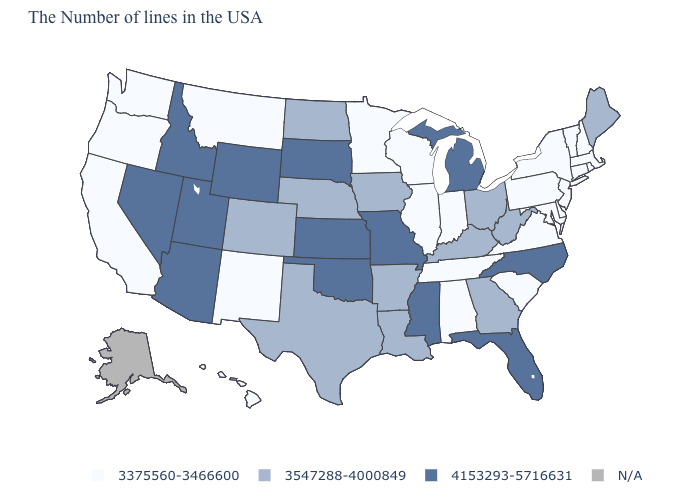What is the value of Florida?
Concise answer only. 4153293-5716631. Among the states that border Delaware , which have the lowest value?
Be succinct. New Jersey, Maryland, Pennsylvania. Is the legend a continuous bar?
Quick response, please. No. What is the value of Mississippi?
Keep it brief. 4153293-5716631. Is the legend a continuous bar?
Concise answer only. No. What is the value of North Carolina?
Short answer required. 4153293-5716631. Among the states that border Vermont , which have the lowest value?
Give a very brief answer. Massachusetts, New Hampshire, New York. Which states have the lowest value in the MidWest?
Give a very brief answer. Indiana, Wisconsin, Illinois, Minnesota. Does the map have missing data?
Answer briefly. Yes. Does Vermont have the highest value in the Northeast?
Write a very short answer. No. Name the states that have a value in the range 3547288-4000849?
Answer briefly. Maine, West Virginia, Ohio, Georgia, Kentucky, Louisiana, Arkansas, Iowa, Nebraska, Texas, North Dakota, Colorado. What is the highest value in the West ?
Be succinct. 4153293-5716631. Does Iowa have the highest value in the MidWest?
Be succinct. No. Name the states that have a value in the range 4153293-5716631?
Answer briefly. North Carolina, Florida, Michigan, Mississippi, Missouri, Kansas, Oklahoma, South Dakota, Wyoming, Utah, Arizona, Idaho, Nevada. Which states have the lowest value in the USA?
Answer briefly. Massachusetts, Rhode Island, New Hampshire, Vermont, Connecticut, New York, New Jersey, Delaware, Maryland, Pennsylvania, Virginia, South Carolina, Indiana, Alabama, Tennessee, Wisconsin, Illinois, Minnesota, New Mexico, Montana, California, Washington, Oregon, Hawaii. 